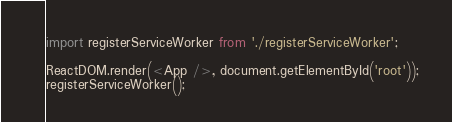Convert code to text. <code><loc_0><loc_0><loc_500><loc_500><_JavaScript_>import registerServiceWorker from './registerServiceWorker';

ReactDOM.render(<App />, document.getElementById('root'));
registerServiceWorker();
</code> 